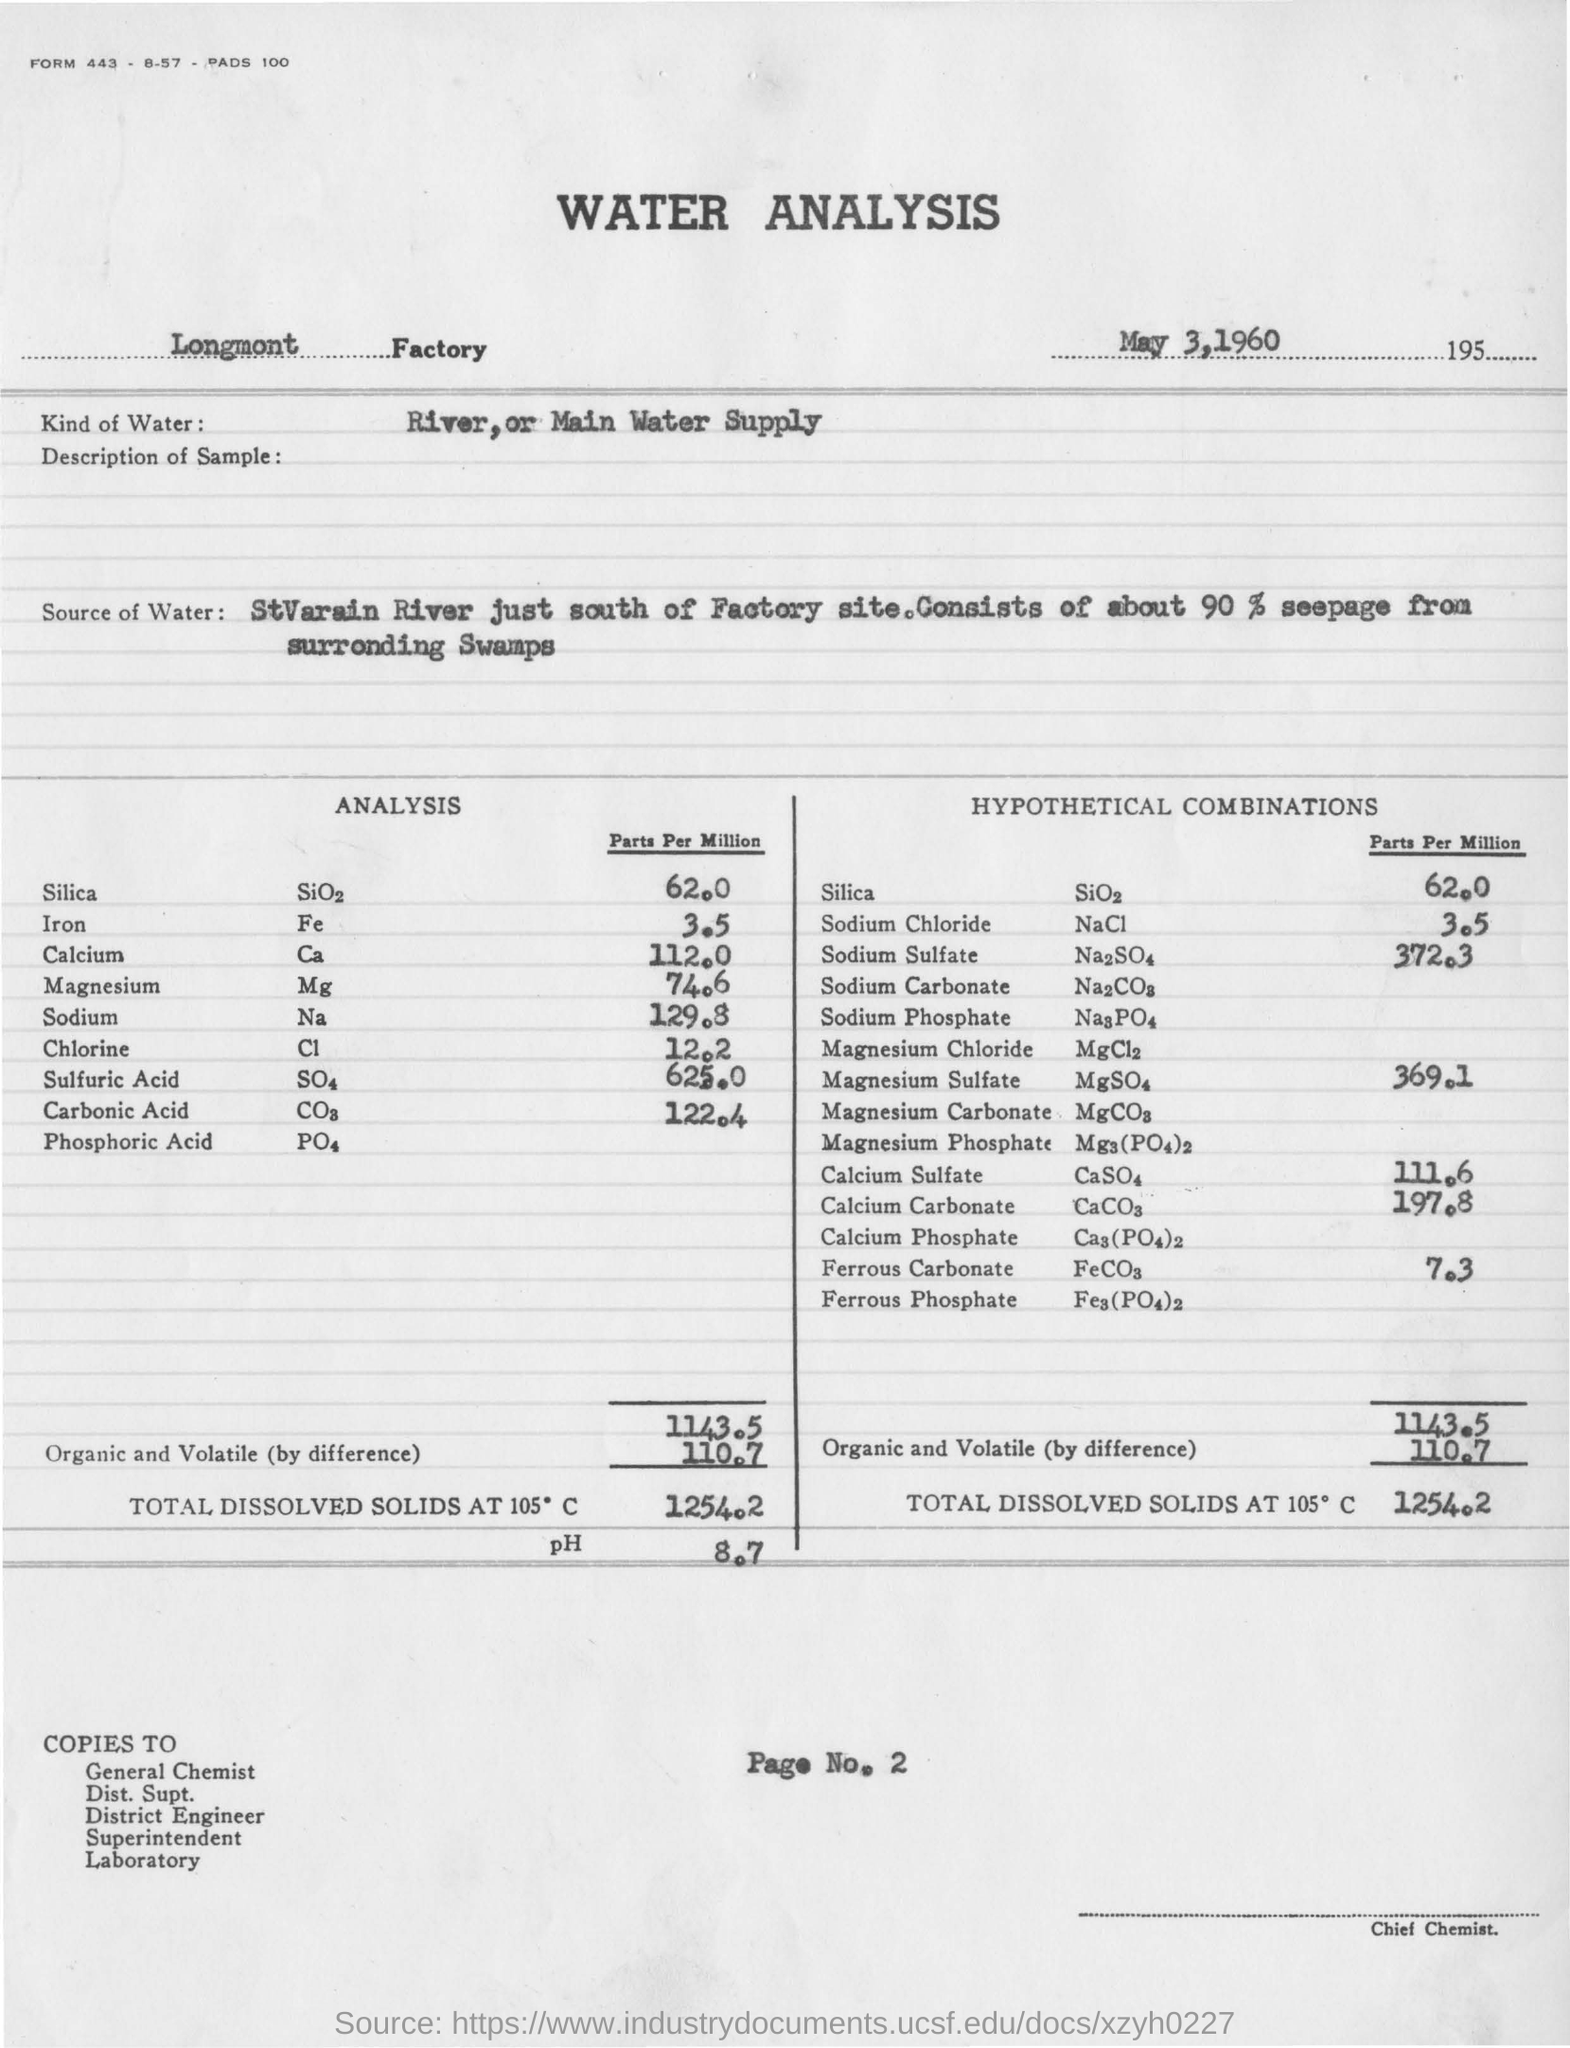Indicate a few pertinent items in this graphic. The study used either river or main water supply for the analysis. The pH value mentioned is 8.7. The analysis took place on May 3, 1960. The report mentions a factory called Longmont factory. 